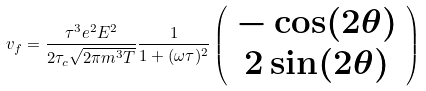<formula> <loc_0><loc_0><loc_500><loc_500>v _ { f } = \frac { \tau ^ { 3 } e ^ { 2 } E ^ { 2 } } { 2 \tau _ { c } \sqrt { 2 \pi m ^ { 3 } T } } \frac { 1 } { 1 + ( \omega \tau ) ^ { 2 } } \left ( \begin{array} { c } - \cos ( 2 \theta ) \\ 2 \sin ( 2 \theta ) \end{array} \right )</formula> 